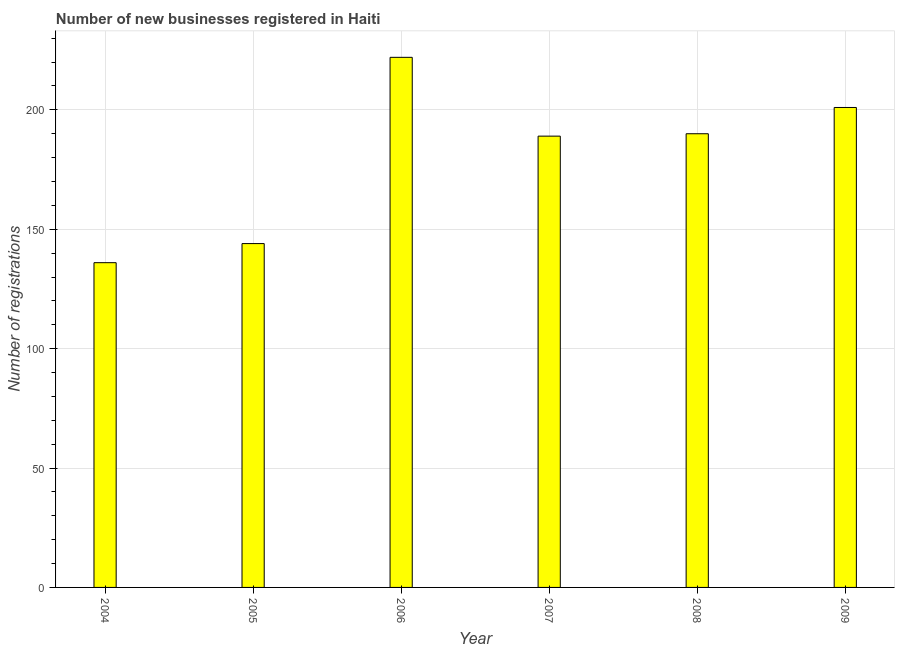Does the graph contain any zero values?
Provide a succinct answer. No. Does the graph contain grids?
Provide a succinct answer. Yes. What is the title of the graph?
Your response must be concise. Number of new businesses registered in Haiti. What is the label or title of the X-axis?
Provide a short and direct response. Year. What is the label or title of the Y-axis?
Make the answer very short. Number of registrations. What is the number of new business registrations in 2007?
Offer a very short reply. 189. Across all years, what is the maximum number of new business registrations?
Ensure brevity in your answer.  222. Across all years, what is the minimum number of new business registrations?
Give a very brief answer. 136. What is the sum of the number of new business registrations?
Your response must be concise. 1082. What is the average number of new business registrations per year?
Your answer should be very brief. 180. What is the median number of new business registrations?
Your response must be concise. 189.5. Do a majority of the years between 2008 and 2004 (inclusive) have number of new business registrations greater than 100 ?
Provide a short and direct response. Yes. What is the ratio of the number of new business registrations in 2006 to that in 2009?
Your answer should be compact. 1.1. Is the difference between the number of new business registrations in 2007 and 2008 greater than the difference between any two years?
Your answer should be compact. No. Is the sum of the number of new business registrations in 2005 and 2009 greater than the maximum number of new business registrations across all years?
Give a very brief answer. Yes. In how many years, is the number of new business registrations greater than the average number of new business registrations taken over all years?
Provide a short and direct response. 4. How many bars are there?
Offer a very short reply. 6. How many years are there in the graph?
Provide a succinct answer. 6. What is the difference between two consecutive major ticks on the Y-axis?
Keep it short and to the point. 50. What is the Number of registrations of 2004?
Provide a short and direct response. 136. What is the Number of registrations in 2005?
Keep it short and to the point. 144. What is the Number of registrations of 2006?
Your answer should be very brief. 222. What is the Number of registrations in 2007?
Make the answer very short. 189. What is the Number of registrations of 2008?
Your response must be concise. 190. What is the Number of registrations in 2009?
Ensure brevity in your answer.  201. What is the difference between the Number of registrations in 2004 and 2006?
Ensure brevity in your answer.  -86. What is the difference between the Number of registrations in 2004 and 2007?
Ensure brevity in your answer.  -53. What is the difference between the Number of registrations in 2004 and 2008?
Offer a terse response. -54. What is the difference between the Number of registrations in 2004 and 2009?
Give a very brief answer. -65. What is the difference between the Number of registrations in 2005 and 2006?
Ensure brevity in your answer.  -78. What is the difference between the Number of registrations in 2005 and 2007?
Ensure brevity in your answer.  -45. What is the difference between the Number of registrations in 2005 and 2008?
Provide a succinct answer. -46. What is the difference between the Number of registrations in 2005 and 2009?
Keep it short and to the point. -57. What is the difference between the Number of registrations in 2006 and 2009?
Give a very brief answer. 21. What is the difference between the Number of registrations in 2007 and 2008?
Keep it short and to the point. -1. What is the difference between the Number of registrations in 2007 and 2009?
Provide a succinct answer. -12. What is the difference between the Number of registrations in 2008 and 2009?
Offer a terse response. -11. What is the ratio of the Number of registrations in 2004 to that in 2005?
Your answer should be very brief. 0.94. What is the ratio of the Number of registrations in 2004 to that in 2006?
Offer a very short reply. 0.61. What is the ratio of the Number of registrations in 2004 to that in 2007?
Your answer should be compact. 0.72. What is the ratio of the Number of registrations in 2004 to that in 2008?
Keep it short and to the point. 0.72. What is the ratio of the Number of registrations in 2004 to that in 2009?
Keep it short and to the point. 0.68. What is the ratio of the Number of registrations in 2005 to that in 2006?
Offer a terse response. 0.65. What is the ratio of the Number of registrations in 2005 to that in 2007?
Keep it short and to the point. 0.76. What is the ratio of the Number of registrations in 2005 to that in 2008?
Keep it short and to the point. 0.76. What is the ratio of the Number of registrations in 2005 to that in 2009?
Offer a terse response. 0.72. What is the ratio of the Number of registrations in 2006 to that in 2007?
Offer a terse response. 1.18. What is the ratio of the Number of registrations in 2006 to that in 2008?
Ensure brevity in your answer.  1.17. What is the ratio of the Number of registrations in 2006 to that in 2009?
Your answer should be compact. 1.1. What is the ratio of the Number of registrations in 2008 to that in 2009?
Give a very brief answer. 0.94. 